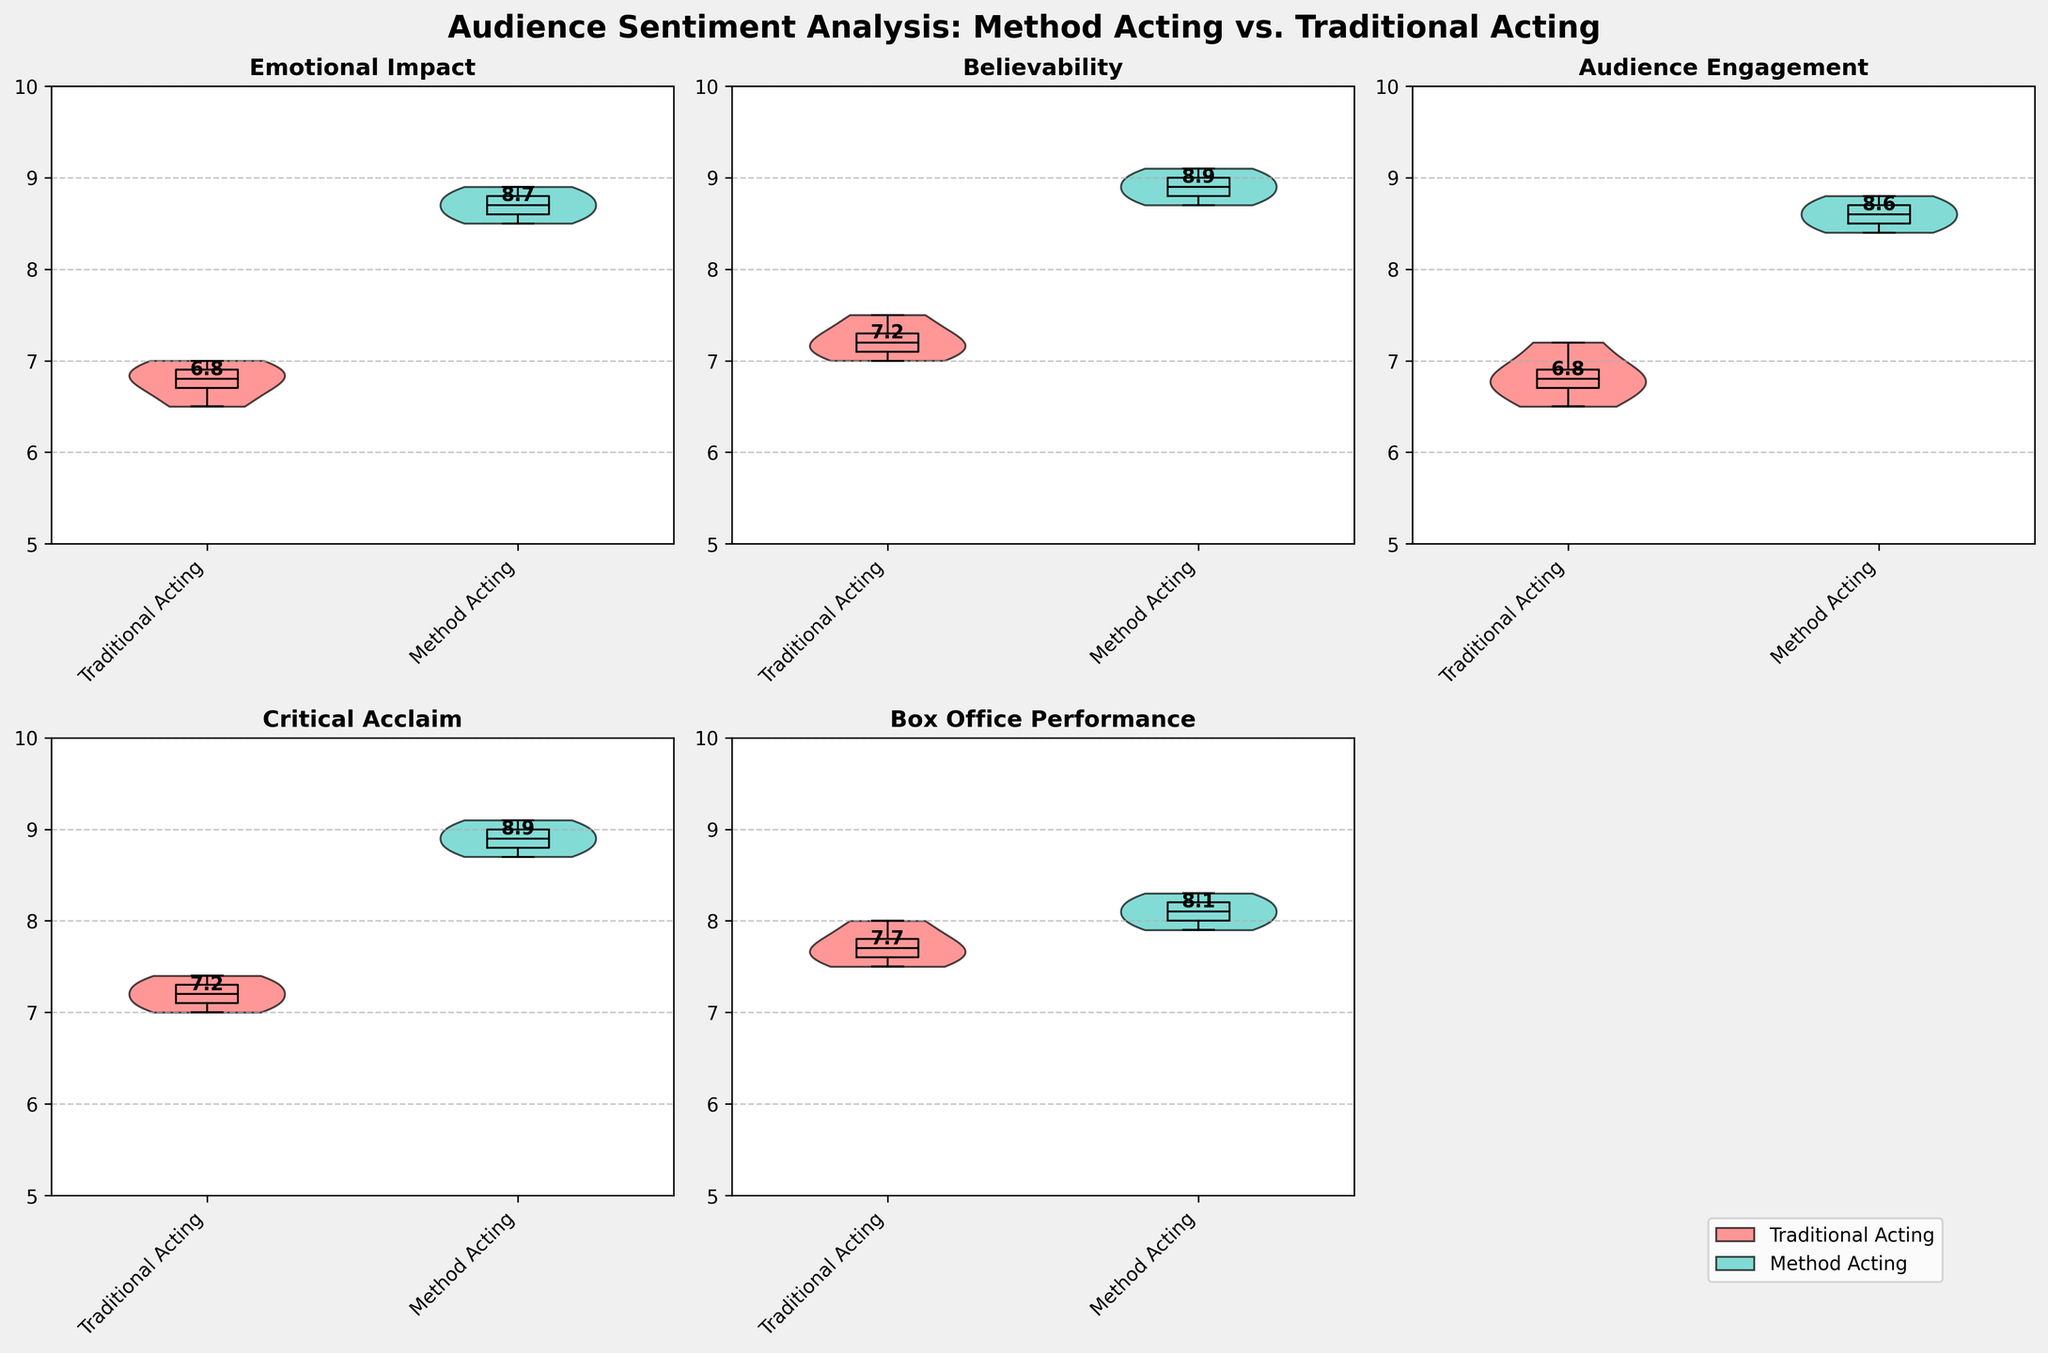What's the median value for Emotional Impact in Method Acting? To find the median value, locate the middle data point out of the values shown in the figure for 'Emotional Impact' in Method Acting. The values are in ascending order: 8.5, 8.6, 8.7, 8.7, 8.8, 8.8, 8.9, 8.9. The median is the average of the two middle numbers.
Answer: 8.7 Which method has a higher overall Audience Engagement? Compare the median value of Audience Engagement between Traditional Acting and Method Acting from the figure. The median value for Method Acting is higher than that of Traditional Acting.
Answer: Method Acting How does the Critical Acclaim for Traditional Acting compare visually to Method Acting? By looking at the two groups in the Critical Acclaim subplot, Method Acting's plot is generally positioned higher (with higher medians and tighter distribution) compared to Traditional Acting, indicating better Critical Acclaim.
Answer: Method Acting is higher Which method has more variability in Emotional Impact? Observe the spread of the data points in the Emotional Impact subplot. The wider the spread, the higher the variability. Traditional Acting shows more scattered points compared to Method Acting.
Answer: Traditional Acting What is the median value of Believability for Traditional Acting? Identify the middle value of the sorted data points for 'Believability' in Traditional Acting, shown in the figure. The points are: 7.0, 7.1, 7.2, 7.3, 7.5, with the median being the middle one.
Answer: 7.2 Between Traditional and Method Acting, which has a higher lower quartile (first quartile) value for Box Office Performance? The first quartile is the value below which 25% of the data fall. Looking at the box plot within the violin plot, for Box Office Performance, the first quartile for Method Acting (around 8.0) is higher than for Traditional Acting.
Answer: Method Acting How is the median Audience Engagement for method acting different from traditional acting? Locate the median line in the Audience Engagement subplot for both methods. The median for Traditional Acting is around 6.8, while for Method Acting it is about 8.6. Subtract 6.8 from 8.6.
Answer: 1.8 higher for Method Acting Which acting method appears to have a more compact distribution of Believability scores? Compare the width of the violin plots and the range of the box plots for Believability. Method Acting shows a more tightly grouped violin plot and box plot, suggesting a more compact distribution.
Answer: Method Acting 